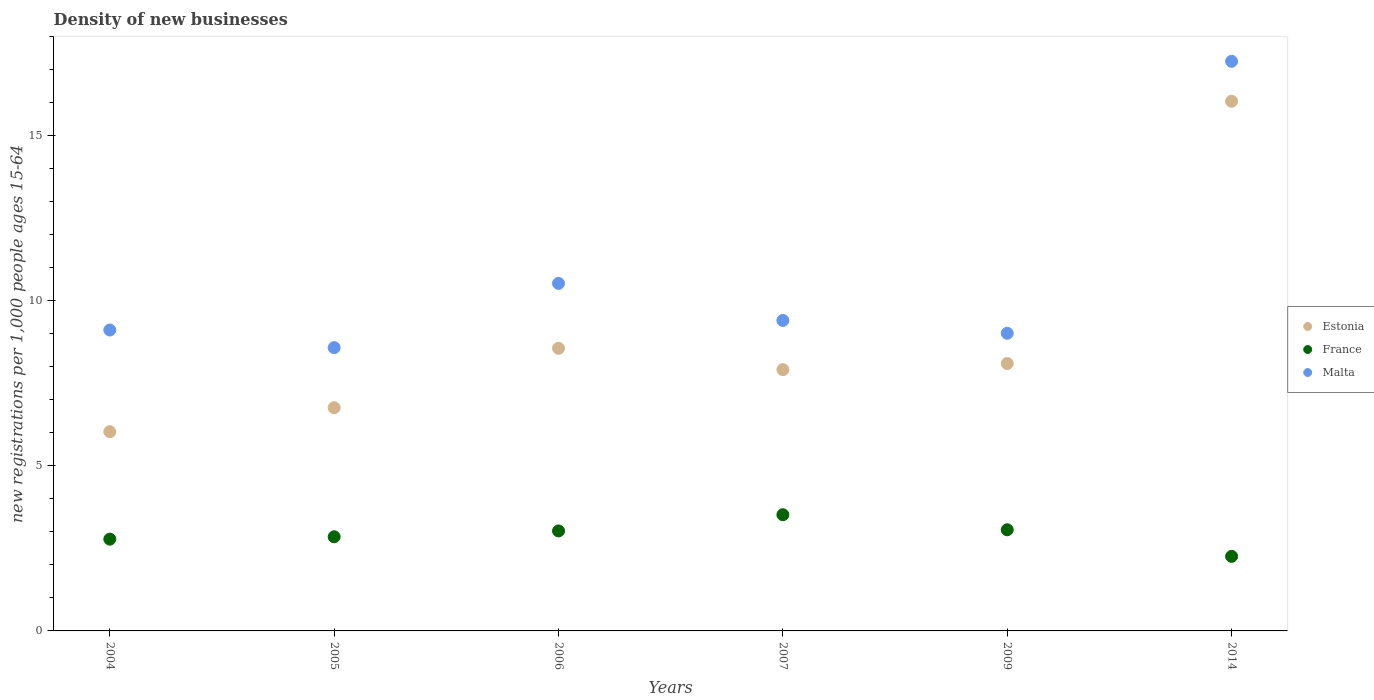How many different coloured dotlines are there?
Your answer should be very brief. 3. Is the number of dotlines equal to the number of legend labels?
Make the answer very short. Yes. What is the number of new registrations in Estonia in 2014?
Provide a short and direct response. 16.05. Across all years, what is the maximum number of new registrations in France?
Provide a short and direct response. 3.52. Across all years, what is the minimum number of new registrations in France?
Your answer should be compact. 2.26. In which year was the number of new registrations in Estonia maximum?
Keep it short and to the point. 2014. What is the total number of new registrations in Estonia in the graph?
Your response must be concise. 53.44. What is the difference between the number of new registrations in Malta in 2006 and that in 2009?
Your response must be concise. 1.51. What is the difference between the number of new registrations in Malta in 2006 and the number of new registrations in France in 2004?
Offer a terse response. 7.75. What is the average number of new registrations in France per year?
Your response must be concise. 2.92. In the year 2006, what is the difference between the number of new registrations in Malta and number of new registrations in Estonia?
Your response must be concise. 1.97. What is the ratio of the number of new registrations in Malta in 2004 to that in 2005?
Ensure brevity in your answer.  1.06. What is the difference between the highest and the second highest number of new registrations in France?
Make the answer very short. 0.46. What is the difference between the highest and the lowest number of new registrations in Malta?
Give a very brief answer. 8.68. Is the sum of the number of new registrations in Malta in 2009 and 2014 greater than the maximum number of new registrations in Estonia across all years?
Keep it short and to the point. Yes. Does the number of new registrations in France monotonically increase over the years?
Provide a short and direct response. No. Is the number of new registrations in France strictly less than the number of new registrations in Estonia over the years?
Offer a very short reply. Yes. How many dotlines are there?
Make the answer very short. 3. How many years are there in the graph?
Your answer should be very brief. 6. Are the values on the major ticks of Y-axis written in scientific E-notation?
Offer a very short reply. No. Where does the legend appear in the graph?
Provide a succinct answer. Center right. What is the title of the graph?
Make the answer very short. Density of new businesses. Does "Burundi" appear as one of the legend labels in the graph?
Offer a very short reply. No. What is the label or title of the X-axis?
Keep it short and to the point. Years. What is the label or title of the Y-axis?
Your answer should be very brief. New registrations per 1,0 people ages 15-64. What is the new registrations per 1,000 people ages 15-64 of Estonia in 2004?
Keep it short and to the point. 6.04. What is the new registrations per 1,000 people ages 15-64 of France in 2004?
Make the answer very short. 2.78. What is the new registrations per 1,000 people ages 15-64 of Malta in 2004?
Make the answer very short. 9.12. What is the new registrations per 1,000 people ages 15-64 in Estonia in 2005?
Provide a short and direct response. 6.76. What is the new registrations per 1,000 people ages 15-64 of France in 2005?
Your answer should be very brief. 2.85. What is the new registrations per 1,000 people ages 15-64 of Malta in 2005?
Your response must be concise. 8.58. What is the new registrations per 1,000 people ages 15-64 of Estonia in 2006?
Your answer should be very brief. 8.56. What is the new registrations per 1,000 people ages 15-64 in France in 2006?
Provide a short and direct response. 3.03. What is the new registrations per 1,000 people ages 15-64 of Malta in 2006?
Offer a very short reply. 10.53. What is the new registrations per 1,000 people ages 15-64 of Estonia in 2007?
Your answer should be very brief. 7.92. What is the new registrations per 1,000 people ages 15-64 of France in 2007?
Offer a very short reply. 3.52. What is the new registrations per 1,000 people ages 15-64 of Malta in 2007?
Offer a terse response. 9.41. What is the new registrations per 1,000 people ages 15-64 of Estonia in 2009?
Ensure brevity in your answer.  8.1. What is the new registrations per 1,000 people ages 15-64 of France in 2009?
Offer a terse response. 3.07. What is the new registrations per 1,000 people ages 15-64 in Malta in 2009?
Your answer should be compact. 9.02. What is the new registrations per 1,000 people ages 15-64 in Estonia in 2014?
Provide a short and direct response. 16.05. What is the new registrations per 1,000 people ages 15-64 in France in 2014?
Offer a terse response. 2.26. What is the new registrations per 1,000 people ages 15-64 of Malta in 2014?
Provide a succinct answer. 17.26. Across all years, what is the maximum new registrations per 1,000 people ages 15-64 in Estonia?
Offer a terse response. 16.05. Across all years, what is the maximum new registrations per 1,000 people ages 15-64 in France?
Offer a terse response. 3.52. Across all years, what is the maximum new registrations per 1,000 people ages 15-64 of Malta?
Your answer should be very brief. 17.26. Across all years, what is the minimum new registrations per 1,000 people ages 15-64 of Estonia?
Offer a terse response. 6.04. Across all years, what is the minimum new registrations per 1,000 people ages 15-64 in France?
Ensure brevity in your answer.  2.26. Across all years, what is the minimum new registrations per 1,000 people ages 15-64 in Malta?
Keep it short and to the point. 8.58. What is the total new registrations per 1,000 people ages 15-64 in Estonia in the graph?
Your response must be concise. 53.44. What is the total new registrations per 1,000 people ages 15-64 in France in the graph?
Provide a succinct answer. 17.51. What is the total new registrations per 1,000 people ages 15-64 in Malta in the graph?
Ensure brevity in your answer.  63.92. What is the difference between the new registrations per 1,000 people ages 15-64 in Estonia in 2004 and that in 2005?
Your response must be concise. -0.73. What is the difference between the new registrations per 1,000 people ages 15-64 in France in 2004 and that in 2005?
Keep it short and to the point. -0.07. What is the difference between the new registrations per 1,000 people ages 15-64 of Malta in 2004 and that in 2005?
Your answer should be compact. 0.53. What is the difference between the new registrations per 1,000 people ages 15-64 in Estonia in 2004 and that in 2006?
Provide a succinct answer. -2.53. What is the difference between the new registrations per 1,000 people ages 15-64 in France in 2004 and that in 2006?
Give a very brief answer. -0.25. What is the difference between the new registrations per 1,000 people ages 15-64 in Malta in 2004 and that in 2006?
Make the answer very short. -1.41. What is the difference between the new registrations per 1,000 people ages 15-64 in Estonia in 2004 and that in 2007?
Provide a short and direct response. -1.88. What is the difference between the new registrations per 1,000 people ages 15-64 in France in 2004 and that in 2007?
Your answer should be very brief. -0.74. What is the difference between the new registrations per 1,000 people ages 15-64 of Malta in 2004 and that in 2007?
Ensure brevity in your answer.  -0.29. What is the difference between the new registrations per 1,000 people ages 15-64 in Estonia in 2004 and that in 2009?
Offer a very short reply. -2.06. What is the difference between the new registrations per 1,000 people ages 15-64 of France in 2004 and that in 2009?
Ensure brevity in your answer.  -0.28. What is the difference between the new registrations per 1,000 people ages 15-64 of Malta in 2004 and that in 2009?
Your answer should be very brief. 0.1. What is the difference between the new registrations per 1,000 people ages 15-64 in Estonia in 2004 and that in 2014?
Keep it short and to the point. -10.01. What is the difference between the new registrations per 1,000 people ages 15-64 of France in 2004 and that in 2014?
Offer a very short reply. 0.52. What is the difference between the new registrations per 1,000 people ages 15-64 in Malta in 2004 and that in 2014?
Your answer should be compact. -8.14. What is the difference between the new registrations per 1,000 people ages 15-64 of Estonia in 2005 and that in 2006?
Keep it short and to the point. -1.8. What is the difference between the new registrations per 1,000 people ages 15-64 in France in 2005 and that in 2006?
Your answer should be compact. -0.18. What is the difference between the new registrations per 1,000 people ages 15-64 of Malta in 2005 and that in 2006?
Give a very brief answer. -1.95. What is the difference between the new registrations per 1,000 people ages 15-64 of Estonia in 2005 and that in 2007?
Give a very brief answer. -1.15. What is the difference between the new registrations per 1,000 people ages 15-64 in France in 2005 and that in 2007?
Your answer should be very brief. -0.67. What is the difference between the new registrations per 1,000 people ages 15-64 in Malta in 2005 and that in 2007?
Your response must be concise. -0.82. What is the difference between the new registrations per 1,000 people ages 15-64 of Estonia in 2005 and that in 2009?
Ensure brevity in your answer.  -1.34. What is the difference between the new registrations per 1,000 people ages 15-64 of France in 2005 and that in 2009?
Your answer should be compact. -0.21. What is the difference between the new registrations per 1,000 people ages 15-64 in Malta in 2005 and that in 2009?
Ensure brevity in your answer.  -0.44. What is the difference between the new registrations per 1,000 people ages 15-64 of Estonia in 2005 and that in 2014?
Ensure brevity in your answer.  -9.29. What is the difference between the new registrations per 1,000 people ages 15-64 of France in 2005 and that in 2014?
Offer a terse response. 0.59. What is the difference between the new registrations per 1,000 people ages 15-64 of Malta in 2005 and that in 2014?
Ensure brevity in your answer.  -8.68. What is the difference between the new registrations per 1,000 people ages 15-64 of Estonia in 2006 and that in 2007?
Ensure brevity in your answer.  0.65. What is the difference between the new registrations per 1,000 people ages 15-64 of France in 2006 and that in 2007?
Provide a short and direct response. -0.49. What is the difference between the new registrations per 1,000 people ages 15-64 in Malta in 2006 and that in 2007?
Ensure brevity in your answer.  1.12. What is the difference between the new registrations per 1,000 people ages 15-64 in Estonia in 2006 and that in 2009?
Make the answer very short. 0.46. What is the difference between the new registrations per 1,000 people ages 15-64 in France in 2006 and that in 2009?
Provide a succinct answer. -0.04. What is the difference between the new registrations per 1,000 people ages 15-64 in Malta in 2006 and that in 2009?
Keep it short and to the point. 1.51. What is the difference between the new registrations per 1,000 people ages 15-64 of Estonia in 2006 and that in 2014?
Provide a succinct answer. -7.49. What is the difference between the new registrations per 1,000 people ages 15-64 of France in 2006 and that in 2014?
Your answer should be compact. 0.77. What is the difference between the new registrations per 1,000 people ages 15-64 in Malta in 2006 and that in 2014?
Give a very brief answer. -6.73. What is the difference between the new registrations per 1,000 people ages 15-64 of Estonia in 2007 and that in 2009?
Your response must be concise. -0.19. What is the difference between the new registrations per 1,000 people ages 15-64 in France in 2007 and that in 2009?
Offer a very short reply. 0.46. What is the difference between the new registrations per 1,000 people ages 15-64 in Malta in 2007 and that in 2009?
Your answer should be very brief. 0.39. What is the difference between the new registrations per 1,000 people ages 15-64 in Estonia in 2007 and that in 2014?
Provide a succinct answer. -8.13. What is the difference between the new registrations per 1,000 people ages 15-64 of France in 2007 and that in 2014?
Make the answer very short. 1.26. What is the difference between the new registrations per 1,000 people ages 15-64 in Malta in 2007 and that in 2014?
Give a very brief answer. -7.85. What is the difference between the new registrations per 1,000 people ages 15-64 in Estonia in 2009 and that in 2014?
Offer a terse response. -7.95. What is the difference between the new registrations per 1,000 people ages 15-64 of France in 2009 and that in 2014?
Ensure brevity in your answer.  0.81. What is the difference between the new registrations per 1,000 people ages 15-64 of Malta in 2009 and that in 2014?
Give a very brief answer. -8.24. What is the difference between the new registrations per 1,000 people ages 15-64 in Estonia in 2004 and the new registrations per 1,000 people ages 15-64 in France in 2005?
Offer a terse response. 3.18. What is the difference between the new registrations per 1,000 people ages 15-64 in Estonia in 2004 and the new registrations per 1,000 people ages 15-64 in Malta in 2005?
Your answer should be compact. -2.55. What is the difference between the new registrations per 1,000 people ages 15-64 in France in 2004 and the new registrations per 1,000 people ages 15-64 in Malta in 2005?
Your response must be concise. -5.8. What is the difference between the new registrations per 1,000 people ages 15-64 of Estonia in 2004 and the new registrations per 1,000 people ages 15-64 of France in 2006?
Give a very brief answer. 3.01. What is the difference between the new registrations per 1,000 people ages 15-64 of Estonia in 2004 and the new registrations per 1,000 people ages 15-64 of Malta in 2006?
Make the answer very short. -4.49. What is the difference between the new registrations per 1,000 people ages 15-64 of France in 2004 and the new registrations per 1,000 people ages 15-64 of Malta in 2006?
Give a very brief answer. -7.75. What is the difference between the new registrations per 1,000 people ages 15-64 of Estonia in 2004 and the new registrations per 1,000 people ages 15-64 of France in 2007?
Offer a terse response. 2.52. What is the difference between the new registrations per 1,000 people ages 15-64 of Estonia in 2004 and the new registrations per 1,000 people ages 15-64 of Malta in 2007?
Give a very brief answer. -3.37. What is the difference between the new registrations per 1,000 people ages 15-64 in France in 2004 and the new registrations per 1,000 people ages 15-64 in Malta in 2007?
Provide a short and direct response. -6.63. What is the difference between the new registrations per 1,000 people ages 15-64 in Estonia in 2004 and the new registrations per 1,000 people ages 15-64 in France in 2009?
Keep it short and to the point. 2.97. What is the difference between the new registrations per 1,000 people ages 15-64 in Estonia in 2004 and the new registrations per 1,000 people ages 15-64 in Malta in 2009?
Your response must be concise. -2.98. What is the difference between the new registrations per 1,000 people ages 15-64 in France in 2004 and the new registrations per 1,000 people ages 15-64 in Malta in 2009?
Your answer should be very brief. -6.24. What is the difference between the new registrations per 1,000 people ages 15-64 in Estonia in 2004 and the new registrations per 1,000 people ages 15-64 in France in 2014?
Your answer should be very brief. 3.78. What is the difference between the new registrations per 1,000 people ages 15-64 in Estonia in 2004 and the new registrations per 1,000 people ages 15-64 in Malta in 2014?
Keep it short and to the point. -11.22. What is the difference between the new registrations per 1,000 people ages 15-64 of France in 2004 and the new registrations per 1,000 people ages 15-64 of Malta in 2014?
Ensure brevity in your answer.  -14.48. What is the difference between the new registrations per 1,000 people ages 15-64 in Estonia in 2005 and the new registrations per 1,000 people ages 15-64 in France in 2006?
Provide a succinct answer. 3.73. What is the difference between the new registrations per 1,000 people ages 15-64 of Estonia in 2005 and the new registrations per 1,000 people ages 15-64 of Malta in 2006?
Keep it short and to the point. -3.77. What is the difference between the new registrations per 1,000 people ages 15-64 in France in 2005 and the new registrations per 1,000 people ages 15-64 in Malta in 2006?
Provide a short and direct response. -7.68. What is the difference between the new registrations per 1,000 people ages 15-64 of Estonia in 2005 and the new registrations per 1,000 people ages 15-64 of France in 2007?
Your response must be concise. 3.24. What is the difference between the new registrations per 1,000 people ages 15-64 in Estonia in 2005 and the new registrations per 1,000 people ages 15-64 in Malta in 2007?
Offer a terse response. -2.64. What is the difference between the new registrations per 1,000 people ages 15-64 of France in 2005 and the new registrations per 1,000 people ages 15-64 of Malta in 2007?
Offer a terse response. -6.56. What is the difference between the new registrations per 1,000 people ages 15-64 of Estonia in 2005 and the new registrations per 1,000 people ages 15-64 of France in 2009?
Keep it short and to the point. 3.7. What is the difference between the new registrations per 1,000 people ages 15-64 in Estonia in 2005 and the new registrations per 1,000 people ages 15-64 in Malta in 2009?
Provide a short and direct response. -2.26. What is the difference between the new registrations per 1,000 people ages 15-64 of France in 2005 and the new registrations per 1,000 people ages 15-64 of Malta in 2009?
Ensure brevity in your answer.  -6.17. What is the difference between the new registrations per 1,000 people ages 15-64 in Estonia in 2005 and the new registrations per 1,000 people ages 15-64 in France in 2014?
Make the answer very short. 4.5. What is the difference between the new registrations per 1,000 people ages 15-64 of Estonia in 2005 and the new registrations per 1,000 people ages 15-64 of Malta in 2014?
Give a very brief answer. -10.5. What is the difference between the new registrations per 1,000 people ages 15-64 of France in 2005 and the new registrations per 1,000 people ages 15-64 of Malta in 2014?
Give a very brief answer. -14.41. What is the difference between the new registrations per 1,000 people ages 15-64 of Estonia in 2006 and the new registrations per 1,000 people ages 15-64 of France in 2007?
Your answer should be compact. 5.04. What is the difference between the new registrations per 1,000 people ages 15-64 of Estonia in 2006 and the new registrations per 1,000 people ages 15-64 of Malta in 2007?
Your answer should be compact. -0.85. What is the difference between the new registrations per 1,000 people ages 15-64 of France in 2006 and the new registrations per 1,000 people ages 15-64 of Malta in 2007?
Provide a succinct answer. -6.38. What is the difference between the new registrations per 1,000 people ages 15-64 of Estonia in 2006 and the new registrations per 1,000 people ages 15-64 of France in 2009?
Your response must be concise. 5.5. What is the difference between the new registrations per 1,000 people ages 15-64 in Estonia in 2006 and the new registrations per 1,000 people ages 15-64 in Malta in 2009?
Keep it short and to the point. -0.46. What is the difference between the new registrations per 1,000 people ages 15-64 in France in 2006 and the new registrations per 1,000 people ages 15-64 in Malta in 2009?
Offer a very short reply. -5.99. What is the difference between the new registrations per 1,000 people ages 15-64 in Estonia in 2006 and the new registrations per 1,000 people ages 15-64 in France in 2014?
Provide a succinct answer. 6.3. What is the difference between the new registrations per 1,000 people ages 15-64 of Estonia in 2006 and the new registrations per 1,000 people ages 15-64 of Malta in 2014?
Your answer should be very brief. -8.7. What is the difference between the new registrations per 1,000 people ages 15-64 in France in 2006 and the new registrations per 1,000 people ages 15-64 in Malta in 2014?
Your answer should be compact. -14.23. What is the difference between the new registrations per 1,000 people ages 15-64 in Estonia in 2007 and the new registrations per 1,000 people ages 15-64 in France in 2009?
Give a very brief answer. 4.85. What is the difference between the new registrations per 1,000 people ages 15-64 of Estonia in 2007 and the new registrations per 1,000 people ages 15-64 of Malta in 2009?
Your answer should be very brief. -1.1. What is the difference between the new registrations per 1,000 people ages 15-64 of France in 2007 and the new registrations per 1,000 people ages 15-64 of Malta in 2009?
Provide a short and direct response. -5.5. What is the difference between the new registrations per 1,000 people ages 15-64 of Estonia in 2007 and the new registrations per 1,000 people ages 15-64 of France in 2014?
Provide a succinct answer. 5.66. What is the difference between the new registrations per 1,000 people ages 15-64 in Estonia in 2007 and the new registrations per 1,000 people ages 15-64 in Malta in 2014?
Keep it short and to the point. -9.34. What is the difference between the new registrations per 1,000 people ages 15-64 of France in 2007 and the new registrations per 1,000 people ages 15-64 of Malta in 2014?
Your answer should be very brief. -13.74. What is the difference between the new registrations per 1,000 people ages 15-64 of Estonia in 2009 and the new registrations per 1,000 people ages 15-64 of France in 2014?
Your answer should be compact. 5.84. What is the difference between the new registrations per 1,000 people ages 15-64 of Estonia in 2009 and the new registrations per 1,000 people ages 15-64 of Malta in 2014?
Your answer should be very brief. -9.16. What is the difference between the new registrations per 1,000 people ages 15-64 of France in 2009 and the new registrations per 1,000 people ages 15-64 of Malta in 2014?
Provide a succinct answer. -14.19. What is the average new registrations per 1,000 people ages 15-64 of Estonia per year?
Ensure brevity in your answer.  8.91. What is the average new registrations per 1,000 people ages 15-64 in France per year?
Your answer should be compact. 2.92. What is the average new registrations per 1,000 people ages 15-64 in Malta per year?
Offer a very short reply. 10.65. In the year 2004, what is the difference between the new registrations per 1,000 people ages 15-64 of Estonia and new registrations per 1,000 people ages 15-64 of France?
Offer a terse response. 3.26. In the year 2004, what is the difference between the new registrations per 1,000 people ages 15-64 in Estonia and new registrations per 1,000 people ages 15-64 in Malta?
Give a very brief answer. -3.08. In the year 2004, what is the difference between the new registrations per 1,000 people ages 15-64 in France and new registrations per 1,000 people ages 15-64 in Malta?
Your answer should be compact. -6.34. In the year 2005, what is the difference between the new registrations per 1,000 people ages 15-64 of Estonia and new registrations per 1,000 people ages 15-64 of France?
Ensure brevity in your answer.  3.91. In the year 2005, what is the difference between the new registrations per 1,000 people ages 15-64 of Estonia and new registrations per 1,000 people ages 15-64 of Malta?
Provide a short and direct response. -1.82. In the year 2005, what is the difference between the new registrations per 1,000 people ages 15-64 in France and new registrations per 1,000 people ages 15-64 in Malta?
Your answer should be compact. -5.73. In the year 2006, what is the difference between the new registrations per 1,000 people ages 15-64 in Estonia and new registrations per 1,000 people ages 15-64 in France?
Offer a terse response. 5.53. In the year 2006, what is the difference between the new registrations per 1,000 people ages 15-64 of Estonia and new registrations per 1,000 people ages 15-64 of Malta?
Keep it short and to the point. -1.97. In the year 2006, what is the difference between the new registrations per 1,000 people ages 15-64 in France and new registrations per 1,000 people ages 15-64 in Malta?
Keep it short and to the point. -7.5. In the year 2007, what is the difference between the new registrations per 1,000 people ages 15-64 of Estonia and new registrations per 1,000 people ages 15-64 of France?
Give a very brief answer. 4.4. In the year 2007, what is the difference between the new registrations per 1,000 people ages 15-64 of Estonia and new registrations per 1,000 people ages 15-64 of Malta?
Your response must be concise. -1.49. In the year 2007, what is the difference between the new registrations per 1,000 people ages 15-64 in France and new registrations per 1,000 people ages 15-64 in Malta?
Your response must be concise. -5.89. In the year 2009, what is the difference between the new registrations per 1,000 people ages 15-64 of Estonia and new registrations per 1,000 people ages 15-64 of France?
Your response must be concise. 5.04. In the year 2009, what is the difference between the new registrations per 1,000 people ages 15-64 of Estonia and new registrations per 1,000 people ages 15-64 of Malta?
Provide a succinct answer. -0.92. In the year 2009, what is the difference between the new registrations per 1,000 people ages 15-64 of France and new registrations per 1,000 people ages 15-64 of Malta?
Offer a very short reply. -5.95. In the year 2014, what is the difference between the new registrations per 1,000 people ages 15-64 of Estonia and new registrations per 1,000 people ages 15-64 of France?
Your response must be concise. 13.79. In the year 2014, what is the difference between the new registrations per 1,000 people ages 15-64 in Estonia and new registrations per 1,000 people ages 15-64 in Malta?
Offer a very short reply. -1.21. In the year 2014, what is the difference between the new registrations per 1,000 people ages 15-64 in France and new registrations per 1,000 people ages 15-64 in Malta?
Provide a succinct answer. -15. What is the ratio of the new registrations per 1,000 people ages 15-64 of Estonia in 2004 to that in 2005?
Offer a very short reply. 0.89. What is the ratio of the new registrations per 1,000 people ages 15-64 of France in 2004 to that in 2005?
Provide a short and direct response. 0.97. What is the ratio of the new registrations per 1,000 people ages 15-64 in Malta in 2004 to that in 2005?
Offer a very short reply. 1.06. What is the ratio of the new registrations per 1,000 people ages 15-64 of Estonia in 2004 to that in 2006?
Your answer should be very brief. 0.71. What is the ratio of the new registrations per 1,000 people ages 15-64 in France in 2004 to that in 2006?
Give a very brief answer. 0.92. What is the ratio of the new registrations per 1,000 people ages 15-64 of Malta in 2004 to that in 2006?
Provide a short and direct response. 0.87. What is the ratio of the new registrations per 1,000 people ages 15-64 of Estonia in 2004 to that in 2007?
Ensure brevity in your answer.  0.76. What is the ratio of the new registrations per 1,000 people ages 15-64 in France in 2004 to that in 2007?
Offer a very short reply. 0.79. What is the ratio of the new registrations per 1,000 people ages 15-64 in Malta in 2004 to that in 2007?
Ensure brevity in your answer.  0.97. What is the ratio of the new registrations per 1,000 people ages 15-64 in Estonia in 2004 to that in 2009?
Your answer should be compact. 0.75. What is the ratio of the new registrations per 1,000 people ages 15-64 of France in 2004 to that in 2009?
Keep it short and to the point. 0.91. What is the ratio of the new registrations per 1,000 people ages 15-64 in Malta in 2004 to that in 2009?
Offer a very short reply. 1.01. What is the ratio of the new registrations per 1,000 people ages 15-64 of Estonia in 2004 to that in 2014?
Ensure brevity in your answer.  0.38. What is the ratio of the new registrations per 1,000 people ages 15-64 in France in 2004 to that in 2014?
Keep it short and to the point. 1.23. What is the ratio of the new registrations per 1,000 people ages 15-64 of Malta in 2004 to that in 2014?
Keep it short and to the point. 0.53. What is the ratio of the new registrations per 1,000 people ages 15-64 in Estonia in 2005 to that in 2006?
Your response must be concise. 0.79. What is the ratio of the new registrations per 1,000 people ages 15-64 in France in 2005 to that in 2006?
Make the answer very short. 0.94. What is the ratio of the new registrations per 1,000 people ages 15-64 of Malta in 2005 to that in 2006?
Ensure brevity in your answer.  0.82. What is the ratio of the new registrations per 1,000 people ages 15-64 in Estonia in 2005 to that in 2007?
Your answer should be very brief. 0.85. What is the ratio of the new registrations per 1,000 people ages 15-64 of France in 2005 to that in 2007?
Provide a succinct answer. 0.81. What is the ratio of the new registrations per 1,000 people ages 15-64 in Malta in 2005 to that in 2007?
Your response must be concise. 0.91. What is the ratio of the new registrations per 1,000 people ages 15-64 in Estonia in 2005 to that in 2009?
Offer a very short reply. 0.83. What is the ratio of the new registrations per 1,000 people ages 15-64 in France in 2005 to that in 2009?
Your answer should be compact. 0.93. What is the ratio of the new registrations per 1,000 people ages 15-64 in Malta in 2005 to that in 2009?
Make the answer very short. 0.95. What is the ratio of the new registrations per 1,000 people ages 15-64 of Estonia in 2005 to that in 2014?
Ensure brevity in your answer.  0.42. What is the ratio of the new registrations per 1,000 people ages 15-64 in France in 2005 to that in 2014?
Your answer should be very brief. 1.26. What is the ratio of the new registrations per 1,000 people ages 15-64 of Malta in 2005 to that in 2014?
Provide a succinct answer. 0.5. What is the ratio of the new registrations per 1,000 people ages 15-64 in Estonia in 2006 to that in 2007?
Keep it short and to the point. 1.08. What is the ratio of the new registrations per 1,000 people ages 15-64 in France in 2006 to that in 2007?
Offer a terse response. 0.86. What is the ratio of the new registrations per 1,000 people ages 15-64 of Malta in 2006 to that in 2007?
Provide a short and direct response. 1.12. What is the ratio of the new registrations per 1,000 people ages 15-64 in Estonia in 2006 to that in 2009?
Provide a short and direct response. 1.06. What is the ratio of the new registrations per 1,000 people ages 15-64 in France in 2006 to that in 2009?
Your answer should be compact. 0.99. What is the ratio of the new registrations per 1,000 people ages 15-64 in Malta in 2006 to that in 2009?
Your response must be concise. 1.17. What is the ratio of the new registrations per 1,000 people ages 15-64 of Estonia in 2006 to that in 2014?
Your answer should be very brief. 0.53. What is the ratio of the new registrations per 1,000 people ages 15-64 of France in 2006 to that in 2014?
Provide a short and direct response. 1.34. What is the ratio of the new registrations per 1,000 people ages 15-64 of Malta in 2006 to that in 2014?
Keep it short and to the point. 0.61. What is the ratio of the new registrations per 1,000 people ages 15-64 of Estonia in 2007 to that in 2009?
Provide a succinct answer. 0.98. What is the ratio of the new registrations per 1,000 people ages 15-64 of France in 2007 to that in 2009?
Offer a very short reply. 1.15. What is the ratio of the new registrations per 1,000 people ages 15-64 of Malta in 2007 to that in 2009?
Provide a short and direct response. 1.04. What is the ratio of the new registrations per 1,000 people ages 15-64 in Estonia in 2007 to that in 2014?
Provide a succinct answer. 0.49. What is the ratio of the new registrations per 1,000 people ages 15-64 in France in 2007 to that in 2014?
Make the answer very short. 1.56. What is the ratio of the new registrations per 1,000 people ages 15-64 in Malta in 2007 to that in 2014?
Your response must be concise. 0.55. What is the ratio of the new registrations per 1,000 people ages 15-64 of Estonia in 2009 to that in 2014?
Provide a short and direct response. 0.5. What is the ratio of the new registrations per 1,000 people ages 15-64 of France in 2009 to that in 2014?
Give a very brief answer. 1.36. What is the ratio of the new registrations per 1,000 people ages 15-64 of Malta in 2009 to that in 2014?
Your response must be concise. 0.52. What is the difference between the highest and the second highest new registrations per 1,000 people ages 15-64 in Estonia?
Ensure brevity in your answer.  7.49. What is the difference between the highest and the second highest new registrations per 1,000 people ages 15-64 in France?
Your answer should be very brief. 0.46. What is the difference between the highest and the second highest new registrations per 1,000 people ages 15-64 of Malta?
Offer a terse response. 6.73. What is the difference between the highest and the lowest new registrations per 1,000 people ages 15-64 in Estonia?
Give a very brief answer. 10.01. What is the difference between the highest and the lowest new registrations per 1,000 people ages 15-64 of France?
Provide a succinct answer. 1.26. What is the difference between the highest and the lowest new registrations per 1,000 people ages 15-64 of Malta?
Ensure brevity in your answer.  8.68. 